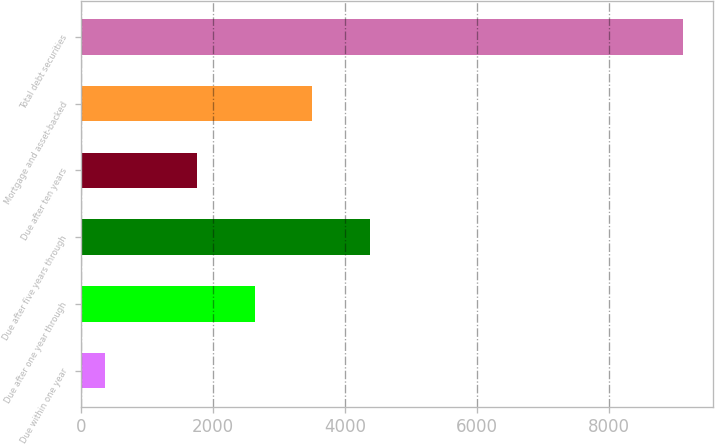<chart> <loc_0><loc_0><loc_500><loc_500><bar_chart><fcel>Due within one year<fcel>Due after one year through<fcel>Due after five years through<fcel>Due after ten years<fcel>Mortgage and asset-backed<fcel>Total debt securities<nl><fcel>359<fcel>2631<fcel>4383<fcel>1755<fcel>3507<fcel>9119<nl></chart> 